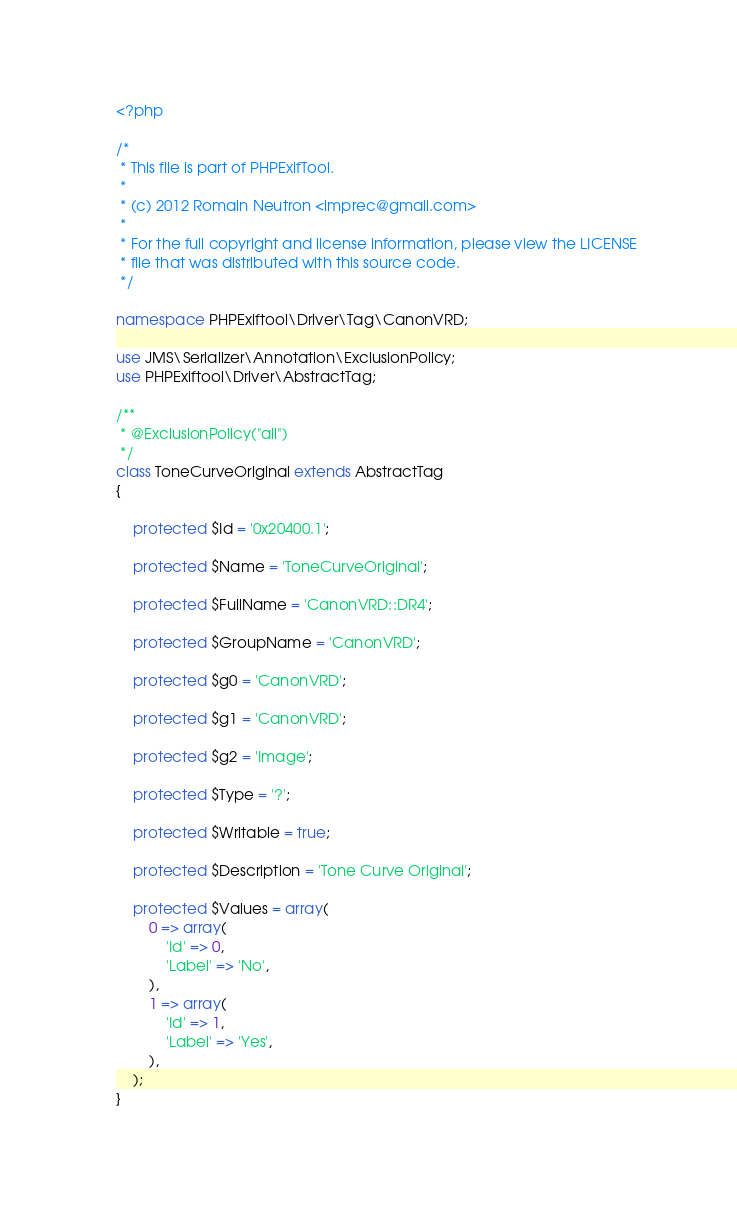Convert code to text. <code><loc_0><loc_0><loc_500><loc_500><_PHP_><?php

/*
 * This file is part of PHPExifTool.
 *
 * (c) 2012 Romain Neutron <imprec@gmail.com>
 *
 * For the full copyright and license information, please view the LICENSE
 * file that was distributed with this source code.
 */

namespace PHPExiftool\Driver\Tag\CanonVRD;

use JMS\Serializer\Annotation\ExclusionPolicy;
use PHPExiftool\Driver\AbstractTag;

/**
 * @ExclusionPolicy("all")
 */
class ToneCurveOriginal extends AbstractTag
{

    protected $Id = '0x20400.1';

    protected $Name = 'ToneCurveOriginal';

    protected $FullName = 'CanonVRD::DR4';

    protected $GroupName = 'CanonVRD';

    protected $g0 = 'CanonVRD';

    protected $g1 = 'CanonVRD';

    protected $g2 = 'Image';

    protected $Type = '?';

    protected $Writable = true;

    protected $Description = 'Tone Curve Original';

    protected $Values = array(
        0 => array(
            'Id' => 0,
            'Label' => 'No',
        ),
        1 => array(
            'Id' => 1,
            'Label' => 'Yes',
        ),
    );
}
</code> 